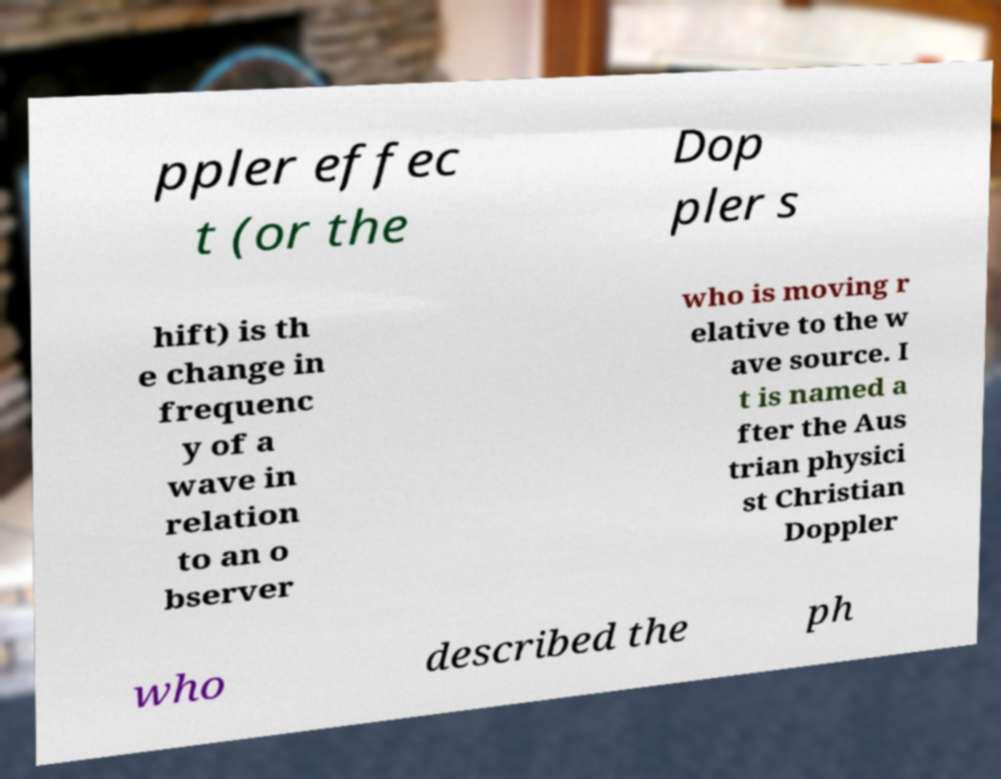Can you read and provide the text displayed in the image?This photo seems to have some interesting text. Can you extract and type it out for me? ppler effec t (or the Dop pler s hift) is th e change in frequenc y of a wave in relation to an o bserver who is moving r elative to the w ave source. I t is named a fter the Aus trian physici st Christian Doppler who described the ph 